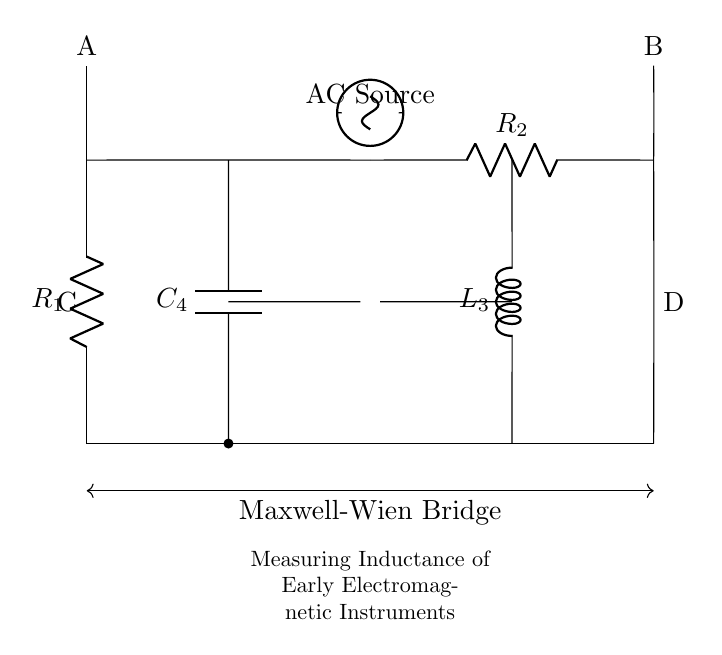What are the components in this circuit? The components include two resistors, one capacitor, and one inductor. These can be identified by their labels in the circuit diagram: R1, R2, C4, and L3.
Answer: resistors, capacitor, inductor What is the purpose of the Maxwell-Wien bridge? The purpose is to measure the inductance of early electromagnetic instruments by balancing the bridge. The arrangement of components allows for precise measurement of the unknown inductance when the bridge is balanced.
Answer: measure inductance What is the identification of the detector in the circuit? The detector is indicated by its position and symbol in the circuit, located between nodes C and D. This is where the measurement taking place is reflected.
Answer: detector How many resistors are there in the Maxwell-Wien bridge? There are two resistors in the circuit, as indicated by the labels R1 and R2. They form part of the balancing mechanism for the inductance measurement.
Answer: two What type of voltage source is used in the circuit? The circuit uses an alternating current (AC) voltage source, as indicated by the labeling above the voltage source icon in the diagram.
Answer: AC source What is the role of the capacitor in the Maxwell-Wien bridge? The capacitor serves to balance the bridge by providing a reactive component that counters the inductive reactance of the coil in the bridge. This is essential for accurate measurement of the inductance.
Answer: balance inductance What is the configuration of the connections between the components? The connections are arranged in a form of a bridge circuit, where two arms are resistive (R1 and R2) and one arm contains a capacitor (C4), while the other contains an inductor (L3), facilitating the bridge balance.
Answer: bridge configuration 